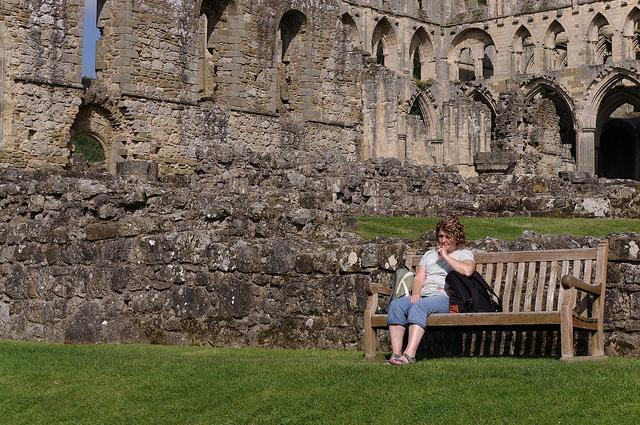What activity happens near and in this structure? tourism 